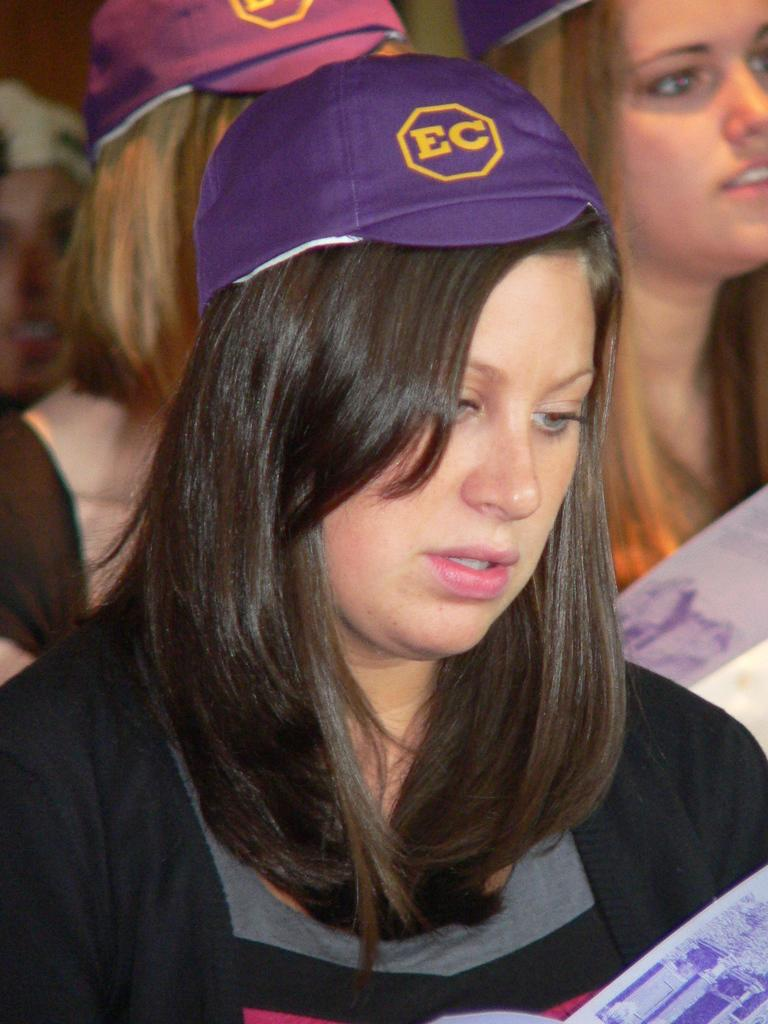<image>
Render a clear and concise summary of the photo. A girl with long dark hair wears a puple cap with EC on it as she looks at a leaflet. 